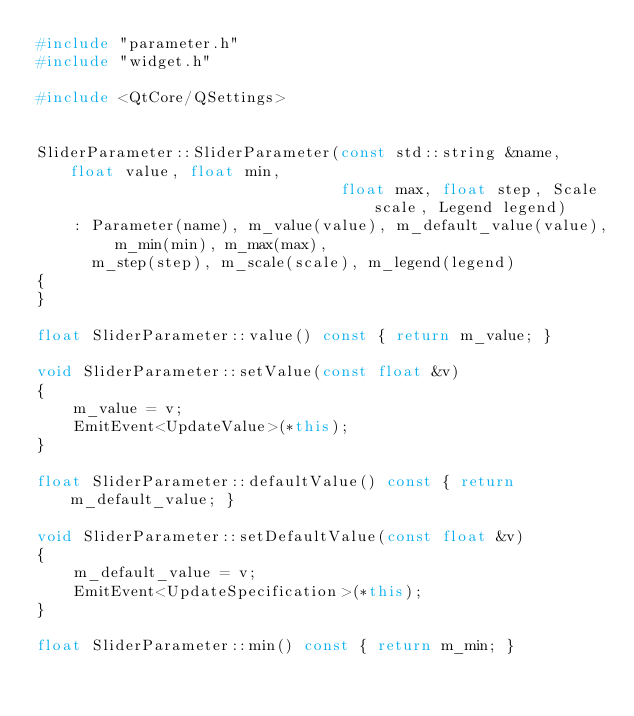Convert code to text. <code><loc_0><loc_0><loc_500><loc_500><_C++_>#include "parameter.h"
#include "widget.h"

#include <QtCore/QSettings>


SliderParameter::SliderParameter(const std::string &name, float value, float min,
                                 float max, float step, Scale scale, Legend legend)
    : Parameter(name), m_value(value), m_default_value(value), m_min(min), m_max(max),
      m_step(step), m_scale(scale), m_legend(legend)
{
}

float SliderParameter::value() const { return m_value; }

void SliderParameter::setValue(const float &v)
{
    m_value = v;
    EmitEvent<UpdateValue>(*this);
}

float SliderParameter::defaultValue() const { return m_default_value; }

void SliderParameter::setDefaultValue(const float &v)
{
    m_default_value = v;
    EmitEvent<UpdateSpecification>(*this);
}

float SliderParameter::min() const { return m_min; }
</code> 